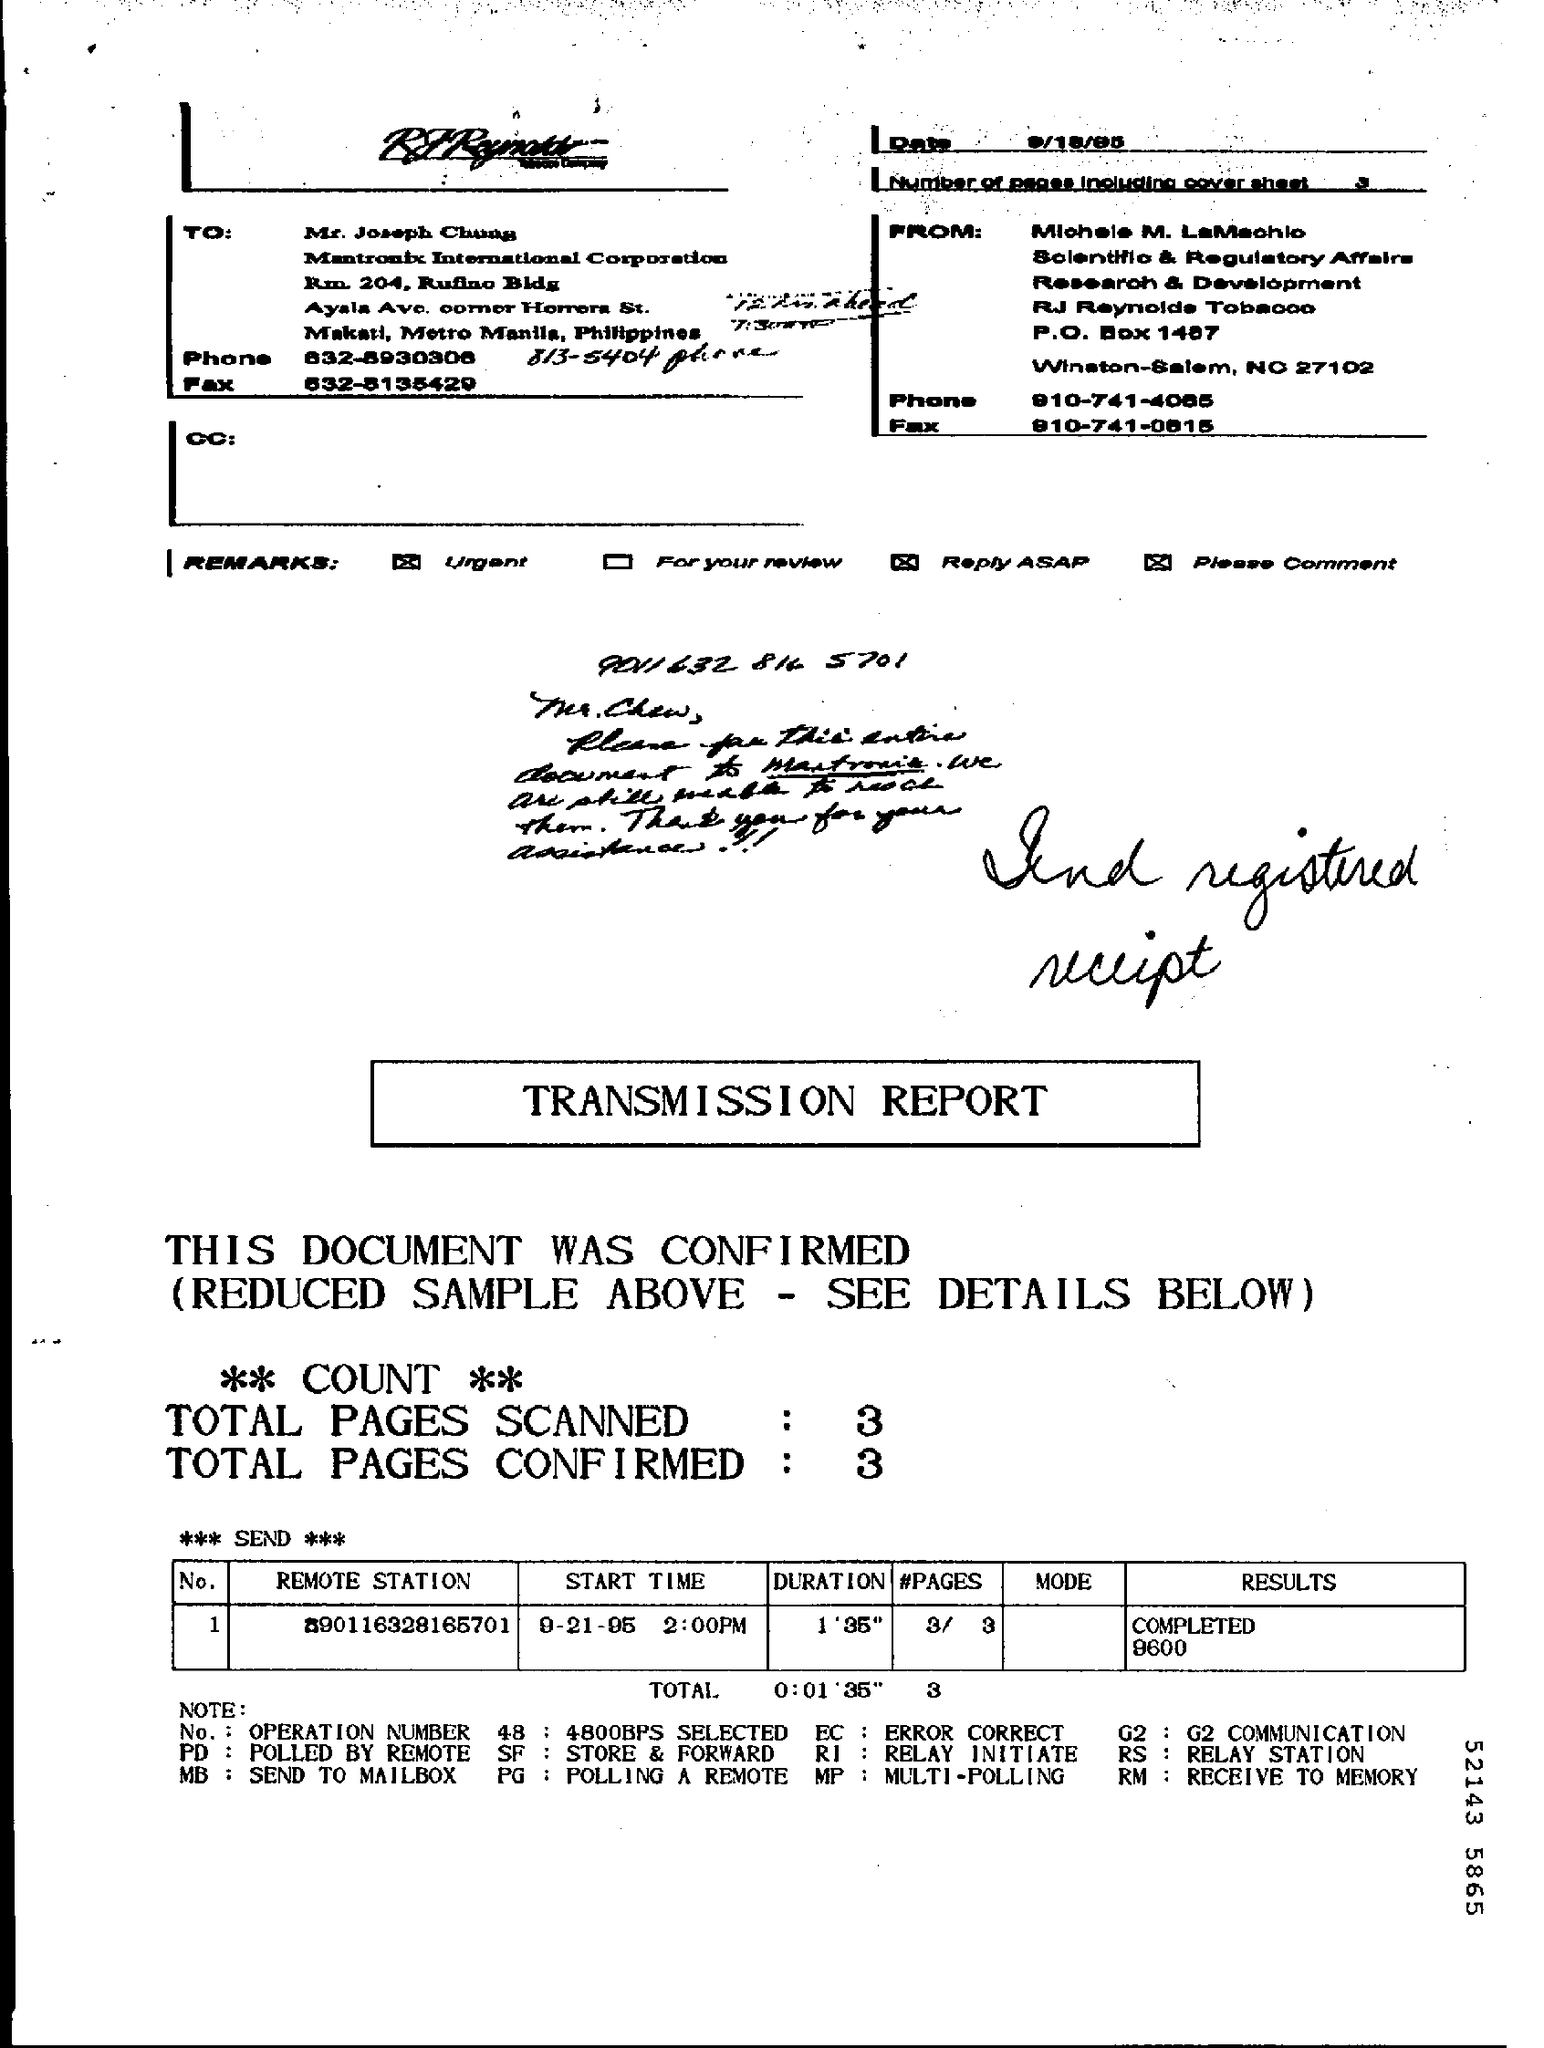List a handful of essential elements in this visual. The start time is September 21, 1995 at 2:00 PM. The total number of pages scanned is 3.. The duration is a measurement of the length of time that something lasts. For example, "What is the duration of 1'35"? It could be interpreted as "What is the length of time that 1 minute and 35 seconds lasts? The total number of confirmed pages is three. 